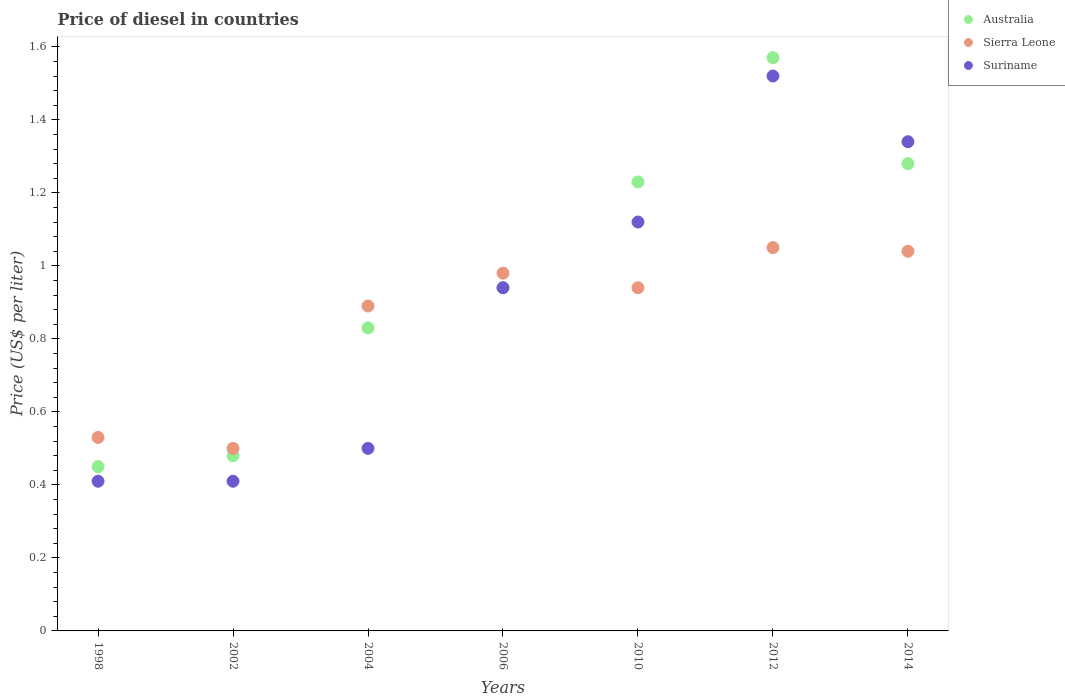How many different coloured dotlines are there?
Your answer should be compact. 3. What is the price of diesel in Australia in 2006?
Offer a very short reply. 0.94. Across all years, what is the maximum price of diesel in Australia?
Make the answer very short. 1.57. Across all years, what is the minimum price of diesel in Suriname?
Make the answer very short. 0.41. In which year was the price of diesel in Sierra Leone maximum?
Your response must be concise. 2012. In which year was the price of diesel in Sierra Leone minimum?
Your answer should be very brief. 2002. What is the total price of diesel in Sierra Leone in the graph?
Offer a very short reply. 5.93. What is the difference between the price of diesel in Sierra Leone in 2006 and that in 2010?
Your answer should be compact. 0.04. What is the difference between the price of diesel in Suriname in 2004 and the price of diesel in Australia in 2012?
Ensure brevity in your answer.  -1.07. What is the average price of diesel in Suriname per year?
Give a very brief answer. 0.89. In the year 2002, what is the difference between the price of diesel in Australia and price of diesel in Sierra Leone?
Offer a very short reply. -0.02. In how many years, is the price of diesel in Suriname greater than 0.68 US$?
Your response must be concise. 4. What is the ratio of the price of diesel in Suriname in 1998 to that in 2004?
Ensure brevity in your answer.  0.82. Is the difference between the price of diesel in Australia in 2010 and 2014 greater than the difference between the price of diesel in Sierra Leone in 2010 and 2014?
Your response must be concise. Yes. What is the difference between the highest and the second highest price of diesel in Suriname?
Provide a succinct answer. 0.18. What is the difference between the highest and the lowest price of diesel in Sierra Leone?
Offer a terse response. 0.55. In how many years, is the price of diesel in Sierra Leone greater than the average price of diesel in Sierra Leone taken over all years?
Your answer should be very brief. 5. Is the price of diesel in Australia strictly greater than the price of diesel in Suriname over the years?
Your answer should be very brief. No. How many dotlines are there?
Offer a very short reply. 3. How many years are there in the graph?
Offer a terse response. 7. Does the graph contain any zero values?
Give a very brief answer. No. Does the graph contain grids?
Make the answer very short. No. How many legend labels are there?
Provide a short and direct response. 3. What is the title of the graph?
Provide a succinct answer. Price of diesel in countries. Does "Liberia" appear as one of the legend labels in the graph?
Your answer should be compact. No. What is the label or title of the Y-axis?
Make the answer very short. Price (US$ per liter). What is the Price (US$ per liter) in Australia in 1998?
Keep it short and to the point. 0.45. What is the Price (US$ per liter) in Sierra Leone in 1998?
Offer a very short reply. 0.53. What is the Price (US$ per liter) in Suriname in 1998?
Ensure brevity in your answer.  0.41. What is the Price (US$ per liter) in Australia in 2002?
Give a very brief answer. 0.48. What is the Price (US$ per liter) in Suriname in 2002?
Provide a short and direct response. 0.41. What is the Price (US$ per liter) in Australia in 2004?
Make the answer very short. 0.83. What is the Price (US$ per liter) of Sierra Leone in 2004?
Your answer should be very brief. 0.89. What is the Price (US$ per liter) of Suriname in 2004?
Ensure brevity in your answer.  0.5. What is the Price (US$ per liter) of Australia in 2006?
Give a very brief answer. 0.94. What is the Price (US$ per liter) in Suriname in 2006?
Offer a terse response. 0.94. What is the Price (US$ per liter) in Australia in 2010?
Provide a succinct answer. 1.23. What is the Price (US$ per liter) of Sierra Leone in 2010?
Provide a short and direct response. 0.94. What is the Price (US$ per liter) of Suriname in 2010?
Your answer should be compact. 1.12. What is the Price (US$ per liter) in Australia in 2012?
Keep it short and to the point. 1.57. What is the Price (US$ per liter) of Suriname in 2012?
Keep it short and to the point. 1.52. What is the Price (US$ per liter) in Australia in 2014?
Give a very brief answer. 1.28. What is the Price (US$ per liter) of Suriname in 2014?
Your answer should be very brief. 1.34. Across all years, what is the maximum Price (US$ per liter) of Australia?
Your response must be concise. 1.57. Across all years, what is the maximum Price (US$ per liter) in Suriname?
Make the answer very short. 1.52. Across all years, what is the minimum Price (US$ per liter) of Australia?
Keep it short and to the point. 0.45. Across all years, what is the minimum Price (US$ per liter) in Sierra Leone?
Keep it short and to the point. 0.5. Across all years, what is the minimum Price (US$ per liter) of Suriname?
Provide a short and direct response. 0.41. What is the total Price (US$ per liter) of Australia in the graph?
Your answer should be compact. 6.78. What is the total Price (US$ per liter) of Sierra Leone in the graph?
Your answer should be compact. 5.93. What is the total Price (US$ per liter) in Suriname in the graph?
Your response must be concise. 6.24. What is the difference between the Price (US$ per liter) of Australia in 1998 and that in 2002?
Provide a succinct answer. -0.03. What is the difference between the Price (US$ per liter) of Australia in 1998 and that in 2004?
Provide a succinct answer. -0.38. What is the difference between the Price (US$ per liter) of Sierra Leone in 1998 and that in 2004?
Your response must be concise. -0.36. What is the difference between the Price (US$ per liter) of Suriname in 1998 and that in 2004?
Your answer should be compact. -0.09. What is the difference between the Price (US$ per liter) of Australia in 1998 and that in 2006?
Provide a short and direct response. -0.49. What is the difference between the Price (US$ per liter) of Sierra Leone in 1998 and that in 2006?
Your answer should be very brief. -0.45. What is the difference between the Price (US$ per liter) of Suriname in 1998 and that in 2006?
Offer a terse response. -0.53. What is the difference between the Price (US$ per liter) in Australia in 1998 and that in 2010?
Provide a short and direct response. -0.78. What is the difference between the Price (US$ per liter) in Sierra Leone in 1998 and that in 2010?
Keep it short and to the point. -0.41. What is the difference between the Price (US$ per liter) in Suriname in 1998 and that in 2010?
Keep it short and to the point. -0.71. What is the difference between the Price (US$ per liter) of Australia in 1998 and that in 2012?
Give a very brief answer. -1.12. What is the difference between the Price (US$ per liter) in Sierra Leone in 1998 and that in 2012?
Provide a short and direct response. -0.52. What is the difference between the Price (US$ per liter) of Suriname in 1998 and that in 2012?
Your answer should be compact. -1.11. What is the difference between the Price (US$ per liter) of Australia in 1998 and that in 2014?
Make the answer very short. -0.83. What is the difference between the Price (US$ per liter) of Sierra Leone in 1998 and that in 2014?
Provide a succinct answer. -0.51. What is the difference between the Price (US$ per liter) of Suriname in 1998 and that in 2014?
Offer a terse response. -0.93. What is the difference between the Price (US$ per liter) in Australia in 2002 and that in 2004?
Offer a very short reply. -0.35. What is the difference between the Price (US$ per liter) in Sierra Leone in 2002 and that in 2004?
Ensure brevity in your answer.  -0.39. What is the difference between the Price (US$ per liter) of Suriname in 2002 and that in 2004?
Make the answer very short. -0.09. What is the difference between the Price (US$ per liter) in Australia in 2002 and that in 2006?
Give a very brief answer. -0.46. What is the difference between the Price (US$ per liter) of Sierra Leone in 2002 and that in 2006?
Provide a short and direct response. -0.48. What is the difference between the Price (US$ per liter) of Suriname in 2002 and that in 2006?
Your answer should be very brief. -0.53. What is the difference between the Price (US$ per liter) of Australia in 2002 and that in 2010?
Your answer should be very brief. -0.75. What is the difference between the Price (US$ per liter) of Sierra Leone in 2002 and that in 2010?
Your answer should be compact. -0.44. What is the difference between the Price (US$ per liter) of Suriname in 2002 and that in 2010?
Your response must be concise. -0.71. What is the difference between the Price (US$ per liter) of Australia in 2002 and that in 2012?
Ensure brevity in your answer.  -1.09. What is the difference between the Price (US$ per liter) of Sierra Leone in 2002 and that in 2012?
Provide a succinct answer. -0.55. What is the difference between the Price (US$ per liter) of Suriname in 2002 and that in 2012?
Your answer should be compact. -1.11. What is the difference between the Price (US$ per liter) in Australia in 2002 and that in 2014?
Your response must be concise. -0.8. What is the difference between the Price (US$ per liter) of Sierra Leone in 2002 and that in 2014?
Your response must be concise. -0.54. What is the difference between the Price (US$ per liter) of Suriname in 2002 and that in 2014?
Your answer should be compact. -0.93. What is the difference between the Price (US$ per liter) in Australia in 2004 and that in 2006?
Offer a terse response. -0.11. What is the difference between the Price (US$ per liter) in Sierra Leone in 2004 and that in 2006?
Give a very brief answer. -0.09. What is the difference between the Price (US$ per liter) in Suriname in 2004 and that in 2006?
Give a very brief answer. -0.44. What is the difference between the Price (US$ per liter) in Australia in 2004 and that in 2010?
Your answer should be very brief. -0.4. What is the difference between the Price (US$ per liter) in Suriname in 2004 and that in 2010?
Your answer should be compact. -0.62. What is the difference between the Price (US$ per liter) in Australia in 2004 and that in 2012?
Offer a very short reply. -0.74. What is the difference between the Price (US$ per liter) of Sierra Leone in 2004 and that in 2012?
Provide a succinct answer. -0.16. What is the difference between the Price (US$ per liter) of Suriname in 2004 and that in 2012?
Your response must be concise. -1.02. What is the difference between the Price (US$ per liter) in Australia in 2004 and that in 2014?
Offer a very short reply. -0.45. What is the difference between the Price (US$ per liter) in Sierra Leone in 2004 and that in 2014?
Your answer should be compact. -0.15. What is the difference between the Price (US$ per liter) of Suriname in 2004 and that in 2014?
Ensure brevity in your answer.  -0.84. What is the difference between the Price (US$ per liter) in Australia in 2006 and that in 2010?
Your answer should be compact. -0.29. What is the difference between the Price (US$ per liter) in Sierra Leone in 2006 and that in 2010?
Provide a succinct answer. 0.04. What is the difference between the Price (US$ per liter) in Suriname in 2006 and that in 2010?
Offer a very short reply. -0.18. What is the difference between the Price (US$ per liter) of Australia in 2006 and that in 2012?
Offer a very short reply. -0.63. What is the difference between the Price (US$ per liter) of Sierra Leone in 2006 and that in 2012?
Give a very brief answer. -0.07. What is the difference between the Price (US$ per liter) of Suriname in 2006 and that in 2012?
Provide a short and direct response. -0.58. What is the difference between the Price (US$ per liter) in Australia in 2006 and that in 2014?
Provide a short and direct response. -0.34. What is the difference between the Price (US$ per liter) of Sierra Leone in 2006 and that in 2014?
Your answer should be very brief. -0.06. What is the difference between the Price (US$ per liter) of Australia in 2010 and that in 2012?
Give a very brief answer. -0.34. What is the difference between the Price (US$ per liter) in Sierra Leone in 2010 and that in 2012?
Ensure brevity in your answer.  -0.11. What is the difference between the Price (US$ per liter) of Suriname in 2010 and that in 2014?
Make the answer very short. -0.22. What is the difference between the Price (US$ per liter) of Australia in 2012 and that in 2014?
Provide a succinct answer. 0.29. What is the difference between the Price (US$ per liter) in Sierra Leone in 2012 and that in 2014?
Offer a terse response. 0.01. What is the difference between the Price (US$ per liter) of Suriname in 2012 and that in 2014?
Provide a short and direct response. 0.18. What is the difference between the Price (US$ per liter) of Sierra Leone in 1998 and the Price (US$ per liter) of Suriname in 2002?
Provide a short and direct response. 0.12. What is the difference between the Price (US$ per liter) of Australia in 1998 and the Price (US$ per liter) of Sierra Leone in 2004?
Ensure brevity in your answer.  -0.44. What is the difference between the Price (US$ per liter) of Australia in 1998 and the Price (US$ per liter) of Suriname in 2004?
Your answer should be very brief. -0.05. What is the difference between the Price (US$ per liter) in Australia in 1998 and the Price (US$ per liter) in Sierra Leone in 2006?
Provide a succinct answer. -0.53. What is the difference between the Price (US$ per liter) of Australia in 1998 and the Price (US$ per liter) of Suriname in 2006?
Give a very brief answer. -0.49. What is the difference between the Price (US$ per liter) of Sierra Leone in 1998 and the Price (US$ per liter) of Suriname in 2006?
Keep it short and to the point. -0.41. What is the difference between the Price (US$ per liter) in Australia in 1998 and the Price (US$ per liter) in Sierra Leone in 2010?
Keep it short and to the point. -0.49. What is the difference between the Price (US$ per liter) in Australia in 1998 and the Price (US$ per liter) in Suriname in 2010?
Your answer should be compact. -0.67. What is the difference between the Price (US$ per liter) in Sierra Leone in 1998 and the Price (US$ per liter) in Suriname in 2010?
Your answer should be very brief. -0.59. What is the difference between the Price (US$ per liter) of Australia in 1998 and the Price (US$ per liter) of Sierra Leone in 2012?
Provide a succinct answer. -0.6. What is the difference between the Price (US$ per liter) in Australia in 1998 and the Price (US$ per liter) in Suriname in 2012?
Provide a succinct answer. -1.07. What is the difference between the Price (US$ per liter) of Sierra Leone in 1998 and the Price (US$ per liter) of Suriname in 2012?
Offer a very short reply. -0.99. What is the difference between the Price (US$ per liter) of Australia in 1998 and the Price (US$ per liter) of Sierra Leone in 2014?
Make the answer very short. -0.59. What is the difference between the Price (US$ per liter) of Australia in 1998 and the Price (US$ per liter) of Suriname in 2014?
Provide a succinct answer. -0.89. What is the difference between the Price (US$ per liter) in Sierra Leone in 1998 and the Price (US$ per liter) in Suriname in 2014?
Ensure brevity in your answer.  -0.81. What is the difference between the Price (US$ per liter) in Australia in 2002 and the Price (US$ per liter) in Sierra Leone in 2004?
Your answer should be very brief. -0.41. What is the difference between the Price (US$ per liter) of Australia in 2002 and the Price (US$ per liter) of Suriname in 2004?
Ensure brevity in your answer.  -0.02. What is the difference between the Price (US$ per liter) in Australia in 2002 and the Price (US$ per liter) in Sierra Leone in 2006?
Provide a short and direct response. -0.5. What is the difference between the Price (US$ per liter) of Australia in 2002 and the Price (US$ per liter) of Suriname in 2006?
Provide a short and direct response. -0.46. What is the difference between the Price (US$ per liter) in Sierra Leone in 2002 and the Price (US$ per liter) in Suriname in 2006?
Provide a short and direct response. -0.44. What is the difference between the Price (US$ per liter) of Australia in 2002 and the Price (US$ per liter) of Sierra Leone in 2010?
Make the answer very short. -0.46. What is the difference between the Price (US$ per liter) of Australia in 2002 and the Price (US$ per liter) of Suriname in 2010?
Provide a succinct answer. -0.64. What is the difference between the Price (US$ per liter) of Sierra Leone in 2002 and the Price (US$ per liter) of Suriname in 2010?
Keep it short and to the point. -0.62. What is the difference between the Price (US$ per liter) in Australia in 2002 and the Price (US$ per liter) in Sierra Leone in 2012?
Offer a very short reply. -0.57. What is the difference between the Price (US$ per liter) in Australia in 2002 and the Price (US$ per liter) in Suriname in 2012?
Your answer should be very brief. -1.04. What is the difference between the Price (US$ per liter) in Sierra Leone in 2002 and the Price (US$ per liter) in Suriname in 2012?
Provide a succinct answer. -1.02. What is the difference between the Price (US$ per liter) of Australia in 2002 and the Price (US$ per liter) of Sierra Leone in 2014?
Make the answer very short. -0.56. What is the difference between the Price (US$ per liter) of Australia in 2002 and the Price (US$ per liter) of Suriname in 2014?
Ensure brevity in your answer.  -0.86. What is the difference between the Price (US$ per liter) in Sierra Leone in 2002 and the Price (US$ per liter) in Suriname in 2014?
Your answer should be very brief. -0.84. What is the difference between the Price (US$ per liter) in Australia in 2004 and the Price (US$ per liter) in Sierra Leone in 2006?
Make the answer very short. -0.15. What is the difference between the Price (US$ per liter) of Australia in 2004 and the Price (US$ per liter) of Suriname in 2006?
Provide a short and direct response. -0.11. What is the difference between the Price (US$ per liter) of Australia in 2004 and the Price (US$ per liter) of Sierra Leone in 2010?
Your response must be concise. -0.11. What is the difference between the Price (US$ per liter) of Australia in 2004 and the Price (US$ per liter) of Suriname in 2010?
Your answer should be compact. -0.29. What is the difference between the Price (US$ per liter) of Sierra Leone in 2004 and the Price (US$ per liter) of Suriname in 2010?
Provide a succinct answer. -0.23. What is the difference between the Price (US$ per liter) of Australia in 2004 and the Price (US$ per liter) of Sierra Leone in 2012?
Make the answer very short. -0.22. What is the difference between the Price (US$ per liter) in Australia in 2004 and the Price (US$ per liter) in Suriname in 2012?
Provide a succinct answer. -0.69. What is the difference between the Price (US$ per liter) in Sierra Leone in 2004 and the Price (US$ per liter) in Suriname in 2012?
Your answer should be very brief. -0.63. What is the difference between the Price (US$ per liter) of Australia in 2004 and the Price (US$ per liter) of Sierra Leone in 2014?
Give a very brief answer. -0.21. What is the difference between the Price (US$ per liter) of Australia in 2004 and the Price (US$ per liter) of Suriname in 2014?
Keep it short and to the point. -0.51. What is the difference between the Price (US$ per liter) in Sierra Leone in 2004 and the Price (US$ per liter) in Suriname in 2014?
Your response must be concise. -0.45. What is the difference between the Price (US$ per liter) of Australia in 2006 and the Price (US$ per liter) of Sierra Leone in 2010?
Your response must be concise. 0. What is the difference between the Price (US$ per liter) of Australia in 2006 and the Price (US$ per liter) of Suriname in 2010?
Provide a short and direct response. -0.18. What is the difference between the Price (US$ per liter) in Sierra Leone in 2006 and the Price (US$ per liter) in Suriname in 2010?
Provide a short and direct response. -0.14. What is the difference between the Price (US$ per liter) of Australia in 2006 and the Price (US$ per liter) of Sierra Leone in 2012?
Keep it short and to the point. -0.11. What is the difference between the Price (US$ per liter) of Australia in 2006 and the Price (US$ per liter) of Suriname in 2012?
Make the answer very short. -0.58. What is the difference between the Price (US$ per liter) of Sierra Leone in 2006 and the Price (US$ per liter) of Suriname in 2012?
Keep it short and to the point. -0.54. What is the difference between the Price (US$ per liter) in Australia in 2006 and the Price (US$ per liter) in Suriname in 2014?
Ensure brevity in your answer.  -0.4. What is the difference between the Price (US$ per liter) of Sierra Leone in 2006 and the Price (US$ per liter) of Suriname in 2014?
Ensure brevity in your answer.  -0.36. What is the difference between the Price (US$ per liter) in Australia in 2010 and the Price (US$ per liter) in Sierra Leone in 2012?
Offer a very short reply. 0.18. What is the difference between the Price (US$ per liter) of Australia in 2010 and the Price (US$ per liter) of Suriname in 2012?
Make the answer very short. -0.29. What is the difference between the Price (US$ per liter) in Sierra Leone in 2010 and the Price (US$ per liter) in Suriname in 2012?
Offer a terse response. -0.58. What is the difference between the Price (US$ per liter) of Australia in 2010 and the Price (US$ per liter) of Sierra Leone in 2014?
Make the answer very short. 0.19. What is the difference between the Price (US$ per liter) of Australia in 2010 and the Price (US$ per liter) of Suriname in 2014?
Ensure brevity in your answer.  -0.11. What is the difference between the Price (US$ per liter) in Sierra Leone in 2010 and the Price (US$ per liter) in Suriname in 2014?
Your response must be concise. -0.4. What is the difference between the Price (US$ per liter) in Australia in 2012 and the Price (US$ per liter) in Sierra Leone in 2014?
Make the answer very short. 0.53. What is the difference between the Price (US$ per liter) in Australia in 2012 and the Price (US$ per liter) in Suriname in 2014?
Offer a very short reply. 0.23. What is the difference between the Price (US$ per liter) of Sierra Leone in 2012 and the Price (US$ per liter) of Suriname in 2014?
Provide a succinct answer. -0.29. What is the average Price (US$ per liter) in Australia per year?
Give a very brief answer. 0.97. What is the average Price (US$ per liter) of Sierra Leone per year?
Provide a short and direct response. 0.85. What is the average Price (US$ per liter) of Suriname per year?
Your answer should be very brief. 0.89. In the year 1998, what is the difference between the Price (US$ per liter) of Australia and Price (US$ per liter) of Sierra Leone?
Your answer should be compact. -0.08. In the year 1998, what is the difference between the Price (US$ per liter) of Sierra Leone and Price (US$ per liter) of Suriname?
Your answer should be very brief. 0.12. In the year 2002, what is the difference between the Price (US$ per liter) of Australia and Price (US$ per liter) of Sierra Leone?
Give a very brief answer. -0.02. In the year 2002, what is the difference between the Price (US$ per liter) of Australia and Price (US$ per liter) of Suriname?
Offer a very short reply. 0.07. In the year 2002, what is the difference between the Price (US$ per liter) of Sierra Leone and Price (US$ per liter) of Suriname?
Give a very brief answer. 0.09. In the year 2004, what is the difference between the Price (US$ per liter) in Australia and Price (US$ per liter) in Sierra Leone?
Give a very brief answer. -0.06. In the year 2004, what is the difference between the Price (US$ per liter) in Australia and Price (US$ per liter) in Suriname?
Your answer should be compact. 0.33. In the year 2004, what is the difference between the Price (US$ per liter) of Sierra Leone and Price (US$ per liter) of Suriname?
Offer a very short reply. 0.39. In the year 2006, what is the difference between the Price (US$ per liter) in Australia and Price (US$ per liter) in Sierra Leone?
Offer a terse response. -0.04. In the year 2006, what is the difference between the Price (US$ per liter) of Sierra Leone and Price (US$ per liter) of Suriname?
Offer a terse response. 0.04. In the year 2010, what is the difference between the Price (US$ per liter) in Australia and Price (US$ per liter) in Sierra Leone?
Ensure brevity in your answer.  0.29. In the year 2010, what is the difference between the Price (US$ per liter) of Australia and Price (US$ per liter) of Suriname?
Ensure brevity in your answer.  0.11. In the year 2010, what is the difference between the Price (US$ per liter) of Sierra Leone and Price (US$ per liter) of Suriname?
Provide a succinct answer. -0.18. In the year 2012, what is the difference between the Price (US$ per liter) of Australia and Price (US$ per liter) of Sierra Leone?
Keep it short and to the point. 0.52. In the year 2012, what is the difference between the Price (US$ per liter) in Sierra Leone and Price (US$ per liter) in Suriname?
Make the answer very short. -0.47. In the year 2014, what is the difference between the Price (US$ per liter) of Australia and Price (US$ per liter) of Sierra Leone?
Keep it short and to the point. 0.24. In the year 2014, what is the difference between the Price (US$ per liter) of Australia and Price (US$ per liter) of Suriname?
Make the answer very short. -0.06. In the year 2014, what is the difference between the Price (US$ per liter) of Sierra Leone and Price (US$ per liter) of Suriname?
Your response must be concise. -0.3. What is the ratio of the Price (US$ per liter) in Australia in 1998 to that in 2002?
Give a very brief answer. 0.94. What is the ratio of the Price (US$ per liter) of Sierra Leone in 1998 to that in 2002?
Keep it short and to the point. 1.06. What is the ratio of the Price (US$ per liter) of Australia in 1998 to that in 2004?
Give a very brief answer. 0.54. What is the ratio of the Price (US$ per liter) in Sierra Leone in 1998 to that in 2004?
Your response must be concise. 0.6. What is the ratio of the Price (US$ per liter) in Suriname in 1998 to that in 2004?
Your response must be concise. 0.82. What is the ratio of the Price (US$ per liter) of Australia in 1998 to that in 2006?
Your answer should be very brief. 0.48. What is the ratio of the Price (US$ per liter) in Sierra Leone in 1998 to that in 2006?
Provide a succinct answer. 0.54. What is the ratio of the Price (US$ per liter) in Suriname in 1998 to that in 2006?
Your answer should be very brief. 0.44. What is the ratio of the Price (US$ per liter) in Australia in 1998 to that in 2010?
Offer a terse response. 0.37. What is the ratio of the Price (US$ per liter) of Sierra Leone in 1998 to that in 2010?
Offer a very short reply. 0.56. What is the ratio of the Price (US$ per liter) in Suriname in 1998 to that in 2010?
Keep it short and to the point. 0.37. What is the ratio of the Price (US$ per liter) of Australia in 1998 to that in 2012?
Provide a succinct answer. 0.29. What is the ratio of the Price (US$ per liter) in Sierra Leone in 1998 to that in 2012?
Your response must be concise. 0.5. What is the ratio of the Price (US$ per liter) of Suriname in 1998 to that in 2012?
Keep it short and to the point. 0.27. What is the ratio of the Price (US$ per liter) of Australia in 1998 to that in 2014?
Ensure brevity in your answer.  0.35. What is the ratio of the Price (US$ per liter) in Sierra Leone in 1998 to that in 2014?
Offer a very short reply. 0.51. What is the ratio of the Price (US$ per liter) in Suriname in 1998 to that in 2014?
Provide a succinct answer. 0.31. What is the ratio of the Price (US$ per liter) in Australia in 2002 to that in 2004?
Your response must be concise. 0.58. What is the ratio of the Price (US$ per liter) in Sierra Leone in 2002 to that in 2004?
Provide a succinct answer. 0.56. What is the ratio of the Price (US$ per liter) in Suriname in 2002 to that in 2004?
Offer a terse response. 0.82. What is the ratio of the Price (US$ per liter) in Australia in 2002 to that in 2006?
Keep it short and to the point. 0.51. What is the ratio of the Price (US$ per liter) in Sierra Leone in 2002 to that in 2006?
Offer a terse response. 0.51. What is the ratio of the Price (US$ per liter) in Suriname in 2002 to that in 2006?
Offer a very short reply. 0.44. What is the ratio of the Price (US$ per liter) in Australia in 2002 to that in 2010?
Keep it short and to the point. 0.39. What is the ratio of the Price (US$ per liter) of Sierra Leone in 2002 to that in 2010?
Your response must be concise. 0.53. What is the ratio of the Price (US$ per liter) of Suriname in 2002 to that in 2010?
Keep it short and to the point. 0.37. What is the ratio of the Price (US$ per liter) in Australia in 2002 to that in 2012?
Keep it short and to the point. 0.31. What is the ratio of the Price (US$ per liter) in Sierra Leone in 2002 to that in 2012?
Ensure brevity in your answer.  0.48. What is the ratio of the Price (US$ per liter) of Suriname in 2002 to that in 2012?
Provide a short and direct response. 0.27. What is the ratio of the Price (US$ per liter) of Australia in 2002 to that in 2014?
Your answer should be very brief. 0.38. What is the ratio of the Price (US$ per liter) in Sierra Leone in 2002 to that in 2014?
Keep it short and to the point. 0.48. What is the ratio of the Price (US$ per liter) in Suriname in 2002 to that in 2014?
Give a very brief answer. 0.31. What is the ratio of the Price (US$ per liter) in Australia in 2004 to that in 2006?
Your answer should be compact. 0.88. What is the ratio of the Price (US$ per liter) in Sierra Leone in 2004 to that in 2006?
Ensure brevity in your answer.  0.91. What is the ratio of the Price (US$ per liter) in Suriname in 2004 to that in 2006?
Your answer should be very brief. 0.53. What is the ratio of the Price (US$ per liter) of Australia in 2004 to that in 2010?
Ensure brevity in your answer.  0.67. What is the ratio of the Price (US$ per liter) of Sierra Leone in 2004 to that in 2010?
Offer a terse response. 0.95. What is the ratio of the Price (US$ per liter) in Suriname in 2004 to that in 2010?
Ensure brevity in your answer.  0.45. What is the ratio of the Price (US$ per liter) of Australia in 2004 to that in 2012?
Keep it short and to the point. 0.53. What is the ratio of the Price (US$ per liter) of Sierra Leone in 2004 to that in 2012?
Give a very brief answer. 0.85. What is the ratio of the Price (US$ per liter) of Suriname in 2004 to that in 2012?
Keep it short and to the point. 0.33. What is the ratio of the Price (US$ per liter) in Australia in 2004 to that in 2014?
Make the answer very short. 0.65. What is the ratio of the Price (US$ per liter) in Sierra Leone in 2004 to that in 2014?
Offer a very short reply. 0.86. What is the ratio of the Price (US$ per liter) of Suriname in 2004 to that in 2014?
Give a very brief answer. 0.37. What is the ratio of the Price (US$ per liter) in Australia in 2006 to that in 2010?
Offer a very short reply. 0.76. What is the ratio of the Price (US$ per liter) of Sierra Leone in 2006 to that in 2010?
Ensure brevity in your answer.  1.04. What is the ratio of the Price (US$ per liter) of Suriname in 2006 to that in 2010?
Provide a succinct answer. 0.84. What is the ratio of the Price (US$ per liter) in Australia in 2006 to that in 2012?
Offer a very short reply. 0.6. What is the ratio of the Price (US$ per liter) of Sierra Leone in 2006 to that in 2012?
Your answer should be compact. 0.93. What is the ratio of the Price (US$ per liter) in Suriname in 2006 to that in 2012?
Make the answer very short. 0.62. What is the ratio of the Price (US$ per liter) of Australia in 2006 to that in 2014?
Your answer should be compact. 0.73. What is the ratio of the Price (US$ per liter) of Sierra Leone in 2006 to that in 2014?
Keep it short and to the point. 0.94. What is the ratio of the Price (US$ per liter) in Suriname in 2006 to that in 2014?
Give a very brief answer. 0.7. What is the ratio of the Price (US$ per liter) in Australia in 2010 to that in 2012?
Your response must be concise. 0.78. What is the ratio of the Price (US$ per liter) of Sierra Leone in 2010 to that in 2012?
Offer a very short reply. 0.9. What is the ratio of the Price (US$ per liter) in Suriname in 2010 to that in 2012?
Provide a short and direct response. 0.74. What is the ratio of the Price (US$ per liter) of Australia in 2010 to that in 2014?
Your answer should be very brief. 0.96. What is the ratio of the Price (US$ per liter) in Sierra Leone in 2010 to that in 2014?
Make the answer very short. 0.9. What is the ratio of the Price (US$ per liter) of Suriname in 2010 to that in 2014?
Your answer should be very brief. 0.84. What is the ratio of the Price (US$ per liter) in Australia in 2012 to that in 2014?
Provide a short and direct response. 1.23. What is the ratio of the Price (US$ per liter) of Sierra Leone in 2012 to that in 2014?
Keep it short and to the point. 1.01. What is the ratio of the Price (US$ per liter) of Suriname in 2012 to that in 2014?
Your answer should be very brief. 1.13. What is the difference between the highest and the second highest Price (US$ per liter) of Australia?
Make the answer very short. 0.29. What is the difference between the highest and the second highest Price (US$ per liter) of Sierra Leone?
Provide a succinct answer. 0.01. What is the difference between the highest and the second highest Price (US$ per liter) in Suriname?
Ensure brevity in your answer.  0.18. What is the difference between the highest and the lowest Price (US$ per liter) of Australia?
Offer a very short reply. 1.12. What is the difference between the highest and the lowest Price (US$ per liter) of Sierra Leone?
Your response must be concise. 0.55. What is the difference between the highest and the lowest Price (US$ per liter) of Suriname?
Offer a very short reply. 1.11. 